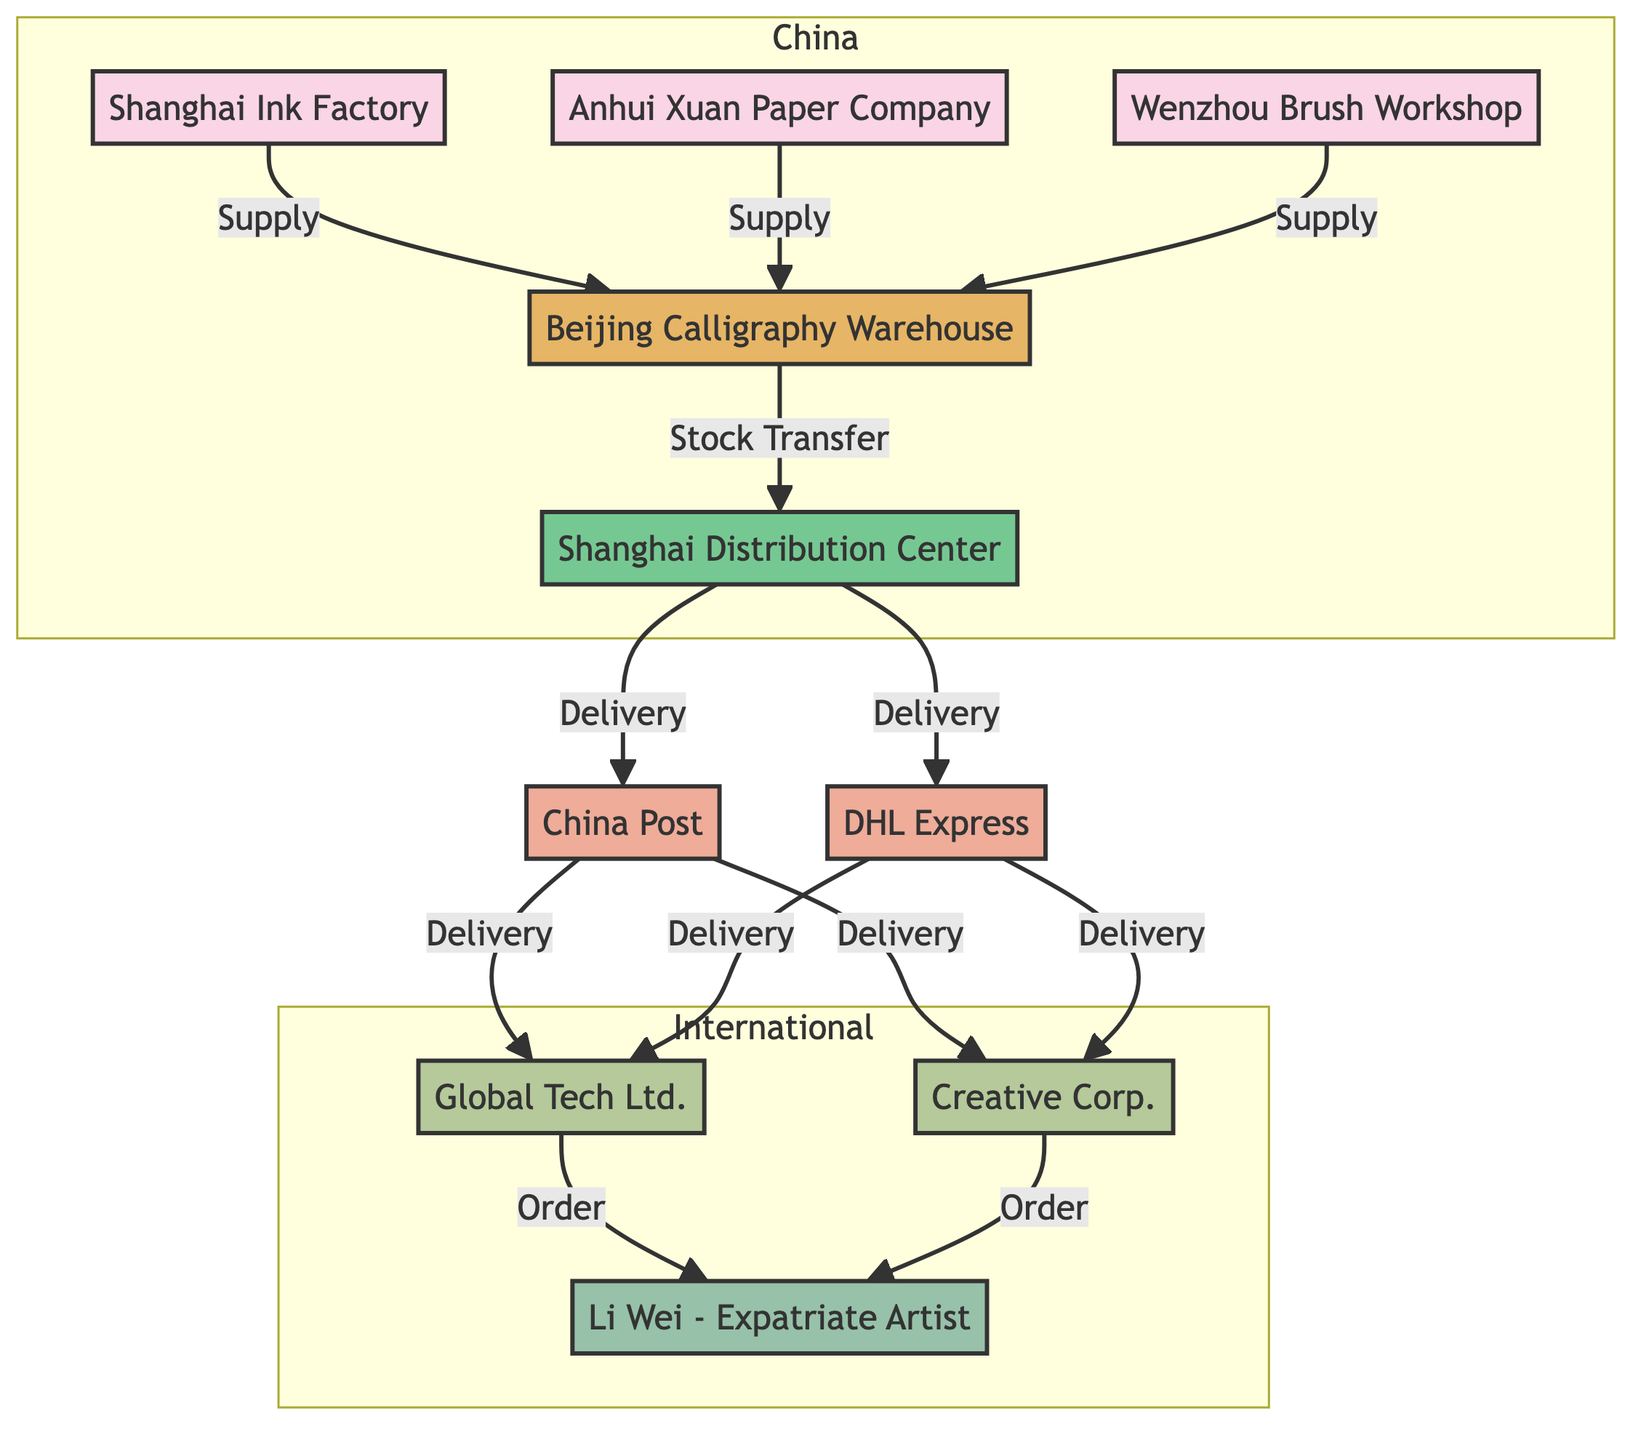What is the type of the node named "Li Wei"? The node named "Li Wei" is identified as an "Expatriate Artist" in the diagram.
Answer: Expatriate Artist How many suppliers are listed in the diagram? Counting the nodes labeled as suppliers, there are three suppliers: Shanghai Ink Factory, Anhui Xuan Paper Company, and Wenzhou Brush Workshop.
Answer: 3 What materials does the "Anhui Xuan Paper Company" supply? The "Anhui Xuan Paper Company" supplies "xuan paper" as indicated in the materials section of the node.
Answer: xuan paper Which clients are connected to the artist? The clients are connected to the artist through orders, specifically, Global Tech Ltd. and Creative Corp. are the clients that order services from the artist.
Answer: Global Tech Ltd., Creative Corp What types of transport services are provided by "DHL Express"? The diagram indicates that "DHL Express" provides "international express" services, which refers to the type of transport they offer.
Answer: international express What is the relationship between "Beijing Calligraphy Warehouse" and "Shanghai Distribution Center"? The relationship is a "Stock Transfer," indicating that goods are transferred from the warehouse to the distribution center.
Answer: Stock Transfer Which materials are supplied by "Shanghai Ink Factory"? From the information in the node, "Shanghai Ink Factory" supplies "inksticks" and "inkstones," showing the specific materials provided by this supplier.
Answer: inksticks, inkstones Identify one method of delivery from the "Shanghai Distribution Center." The diagram shows that one of the methods of delivery from the "Shanghai Distribution Center" is through "China Post," which is listed as one of the transporters.
Answer: China Post In which city is the "Beijing Calligraphy Warehouse" located? The location of the "Beijing Calligraphy Warehouse" is mentioned in the node description as being in "Beijing, China."
Answer: Beijing, China What is the primary purpose of the connections between clients and the artist? The connections between clients and the artist are labeled as "Order," which signifies that clients are placing orders for services offered by the artist.
Answer: Order 